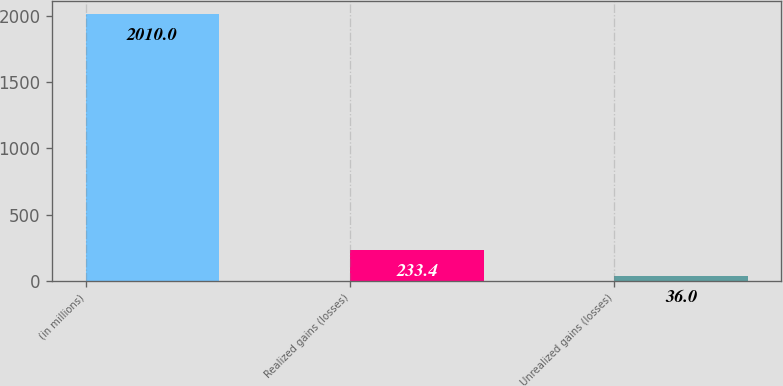Convert chart. <chart><loc_0><loc_0><loc_500><loc_500><bar_chart><fcel>(in millions)<fcel>Realized gains (losses)<fcel>Unrealized gains (losses)<nl><fcel>2010<fcel>233.4<fcel>36<nl></chart> 